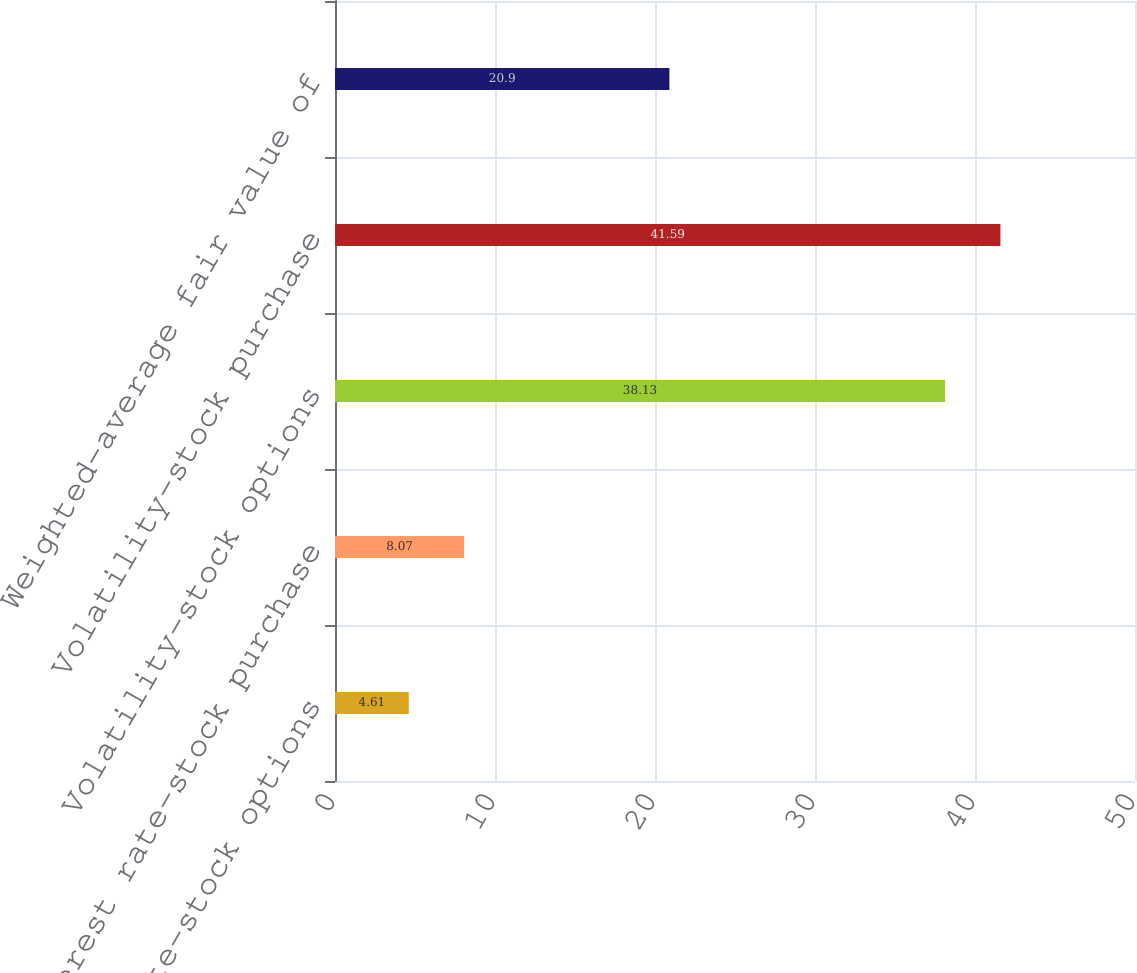<chart> <loc_0><loc_0><loc_500><loc_500><bar_chart><fcel>Interest rate-stock options<fcel>Interest rate-stock purchase<fcel>Volatility-stock options<fcel>Volatility-stock purchase<fcel>Weighted-average fair value of<nl><fcel>4.61<fcel>8.07<fcel>38.13<fcel>41.59<fcel>20.9<nl></chart> 